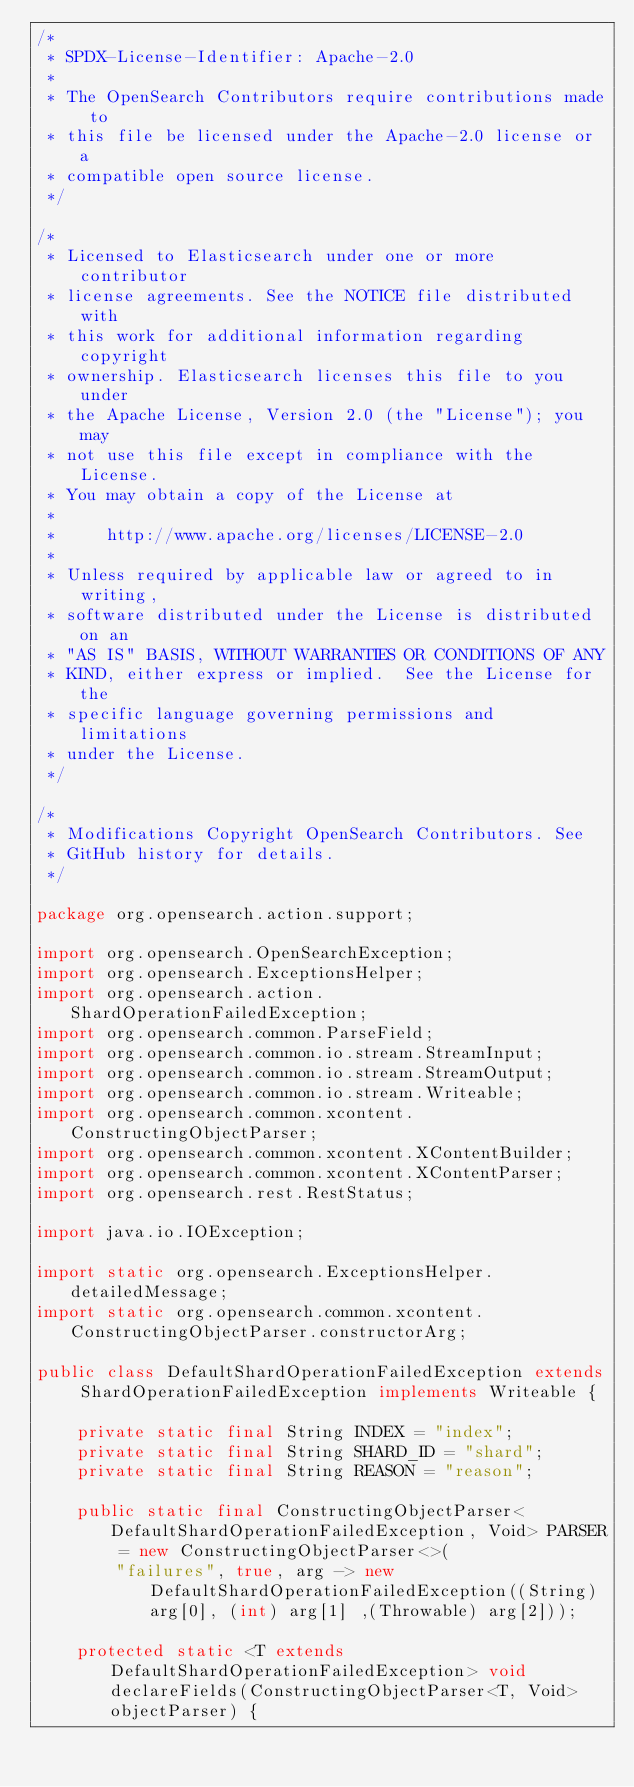<code> <loc_0><loc_0><loc_500><loc_500><_Java_>/*
 * SPDX-License-Identifier: Apache-2.0
 *
 * The OpenSearch Contributors require contributions made to
 * this file be licensed under the Apache-2.0 license or a
 * compatible open source license.
 */

/*
 * Licensed to Elasticsearch under one or more contributor
 * license agreements. See the NOTICE file distributed with
 * this work for additional information regarding copyright
 * ownership. Elasticsearch licenses this file to you under
 * the Apache License, Version 2.0 (the "License"); you may
 * not use this file except in compliance with the License.
 * You may obtain a copy of the License at
 *
 *     http://www.apache.org/licenses/LICENSE-2.0
 *
 * Unless required by applicable law or agreed to in writing,
 * software distributed under the License is distributed on an
 * "AS IS" BASIS, WITHOUT WARRANTIES OR CONDITIONS OF ANY
 * KIND, either express or implied.  See the License for the
 * specific language governing permissions and limitations
 * under the License.
 */

/*
 * Modifications Copyright OpenSearch Contributors. See
 * GitHub history for details.
 */

package org.opensearch.action.support;

import org.opensearch.OpenSearchException;
import org.opensearch.ExceptionsHelper;
import org.opensearch.action.ShardOperationFailedException;
import org.opensearch.common.ParseField;
import org.opensearch.common.io.stream.StreamInput;
import org.opensearch.common.io.stream.StreamOutput;
import org.opensearch.common.io.stream.Writeable;
import org.opensearch.common.xcontent.ConstructingObjectParser;
import org.opensearch.common.xcontent.XContentBuilder;
import org.opensearch.common.xcontent.XContentParser;
import org.opensearch.rest.RestStatus;

import java.io.IOException;

import static org.opensearch.ExceptionsHelper.detailedMessage;
import static org.opensearch.common.xcontent.ConstructingObjectParser.constructorArg;

public class DefaultShardOperationFailedException extends ShardOperationFailedException implements Writeable {

    private static final String INDEX = "index";
    private static final String SHARD_ID = "shard";
    private static final String REASON = "reason";

    public static final ConstructingObjectParser<DefaultShardOperationFailedException, Void> PARSER = new ConstructingObjectParser<>(
        "failures", true, arg -> new DefaultShardOperationFailedException((String) arg[0], (int) arg[1] ,(Throwable) arg[2]));

    protected static <T extends DefaultShardOperationFailedException> void declareFields(ConstructingObjectParser<T, Void> objectParser) {</code> 